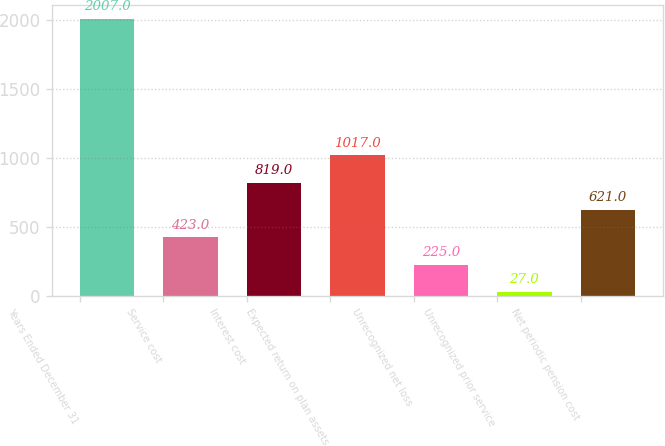<chart> <loc_0><loc_0><loc_500><loc_500><bar_chart><fcel>Years Ended December 31<fcel>Service cost<fcel>Interest cost<fcel>Expected return on plan assets<fcel>Unrecognized net loss<fcel>Unrecognized prior service<fcel>Net periodic pension cost<nl><fcel>2007<fcel>423<fcel>819<fcel>1017<fcel>225<fcel>27<fcel>621<nl></chart> 